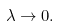<formula> <loc_0><loc_0><loc_500><loc_500>\lambda \rightarrow 0 .</formula> 